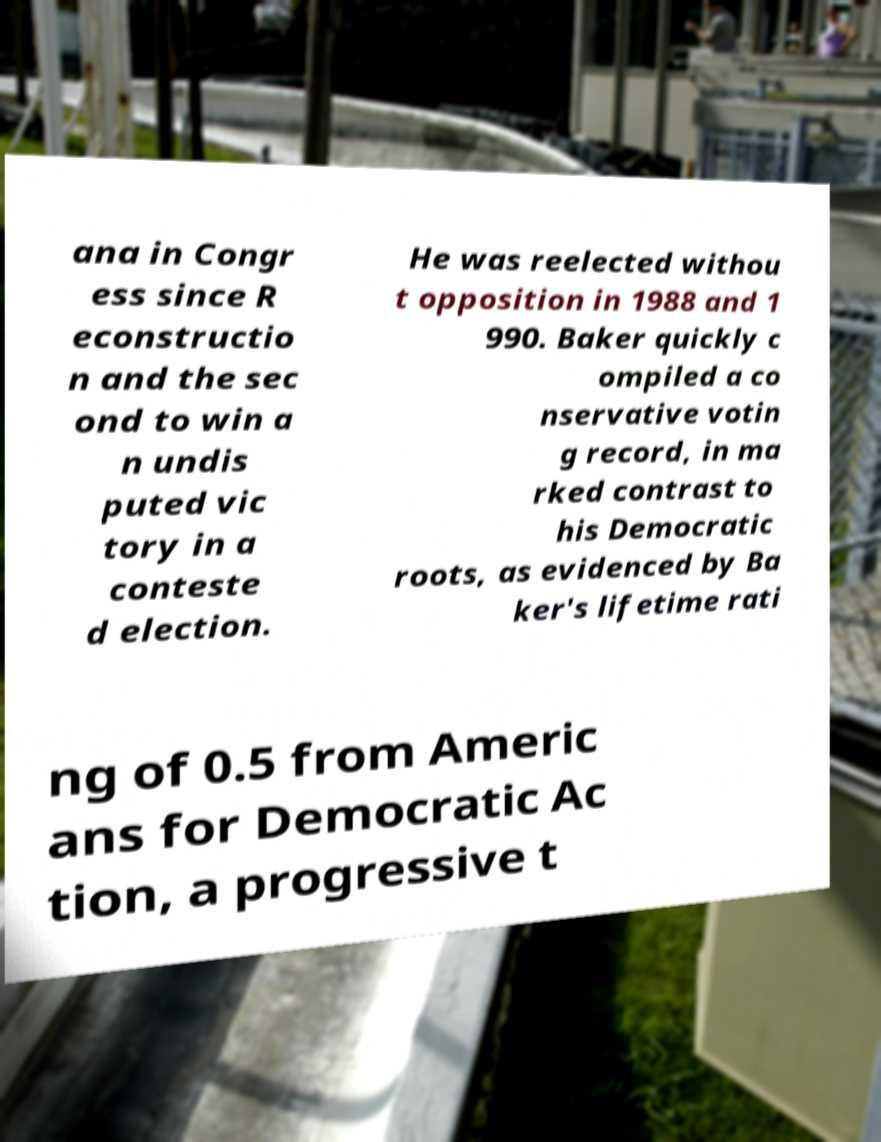Can you accurately transcribe the text from the provided image for me? ana in Congr ess since R econstructio n and the sec ond to win a n undis puted vic tory in a conteste d election. He was reelected withou t opposition in 1988 and 1 990. Baker quickly c ompiled a co nservative votin g record, in ma rked contrast to his Democratic roots, as evidenced by Ba ker's lifetime rati ng of 0.5 from Americ ans for Democratic Ac tion, a progressive t 